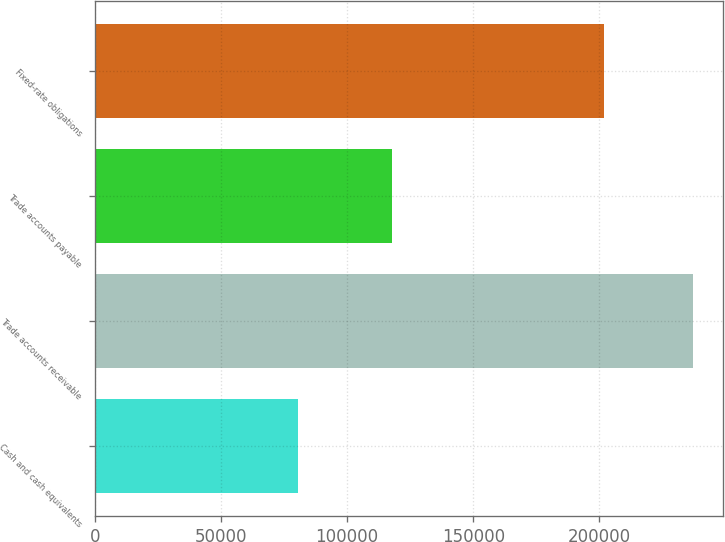<chart> <loc_0><loc_0><loc_500><loc_500><bar_chart><fcel>Cash and cash equivalents<fcel>Trade accounts receivable<fcel>Trade accounts payable<fcel>Fixed-rate obligations<nl><fcel>80628<fcel>237156<fcel>117931<fcel>202010<nl></chart> 